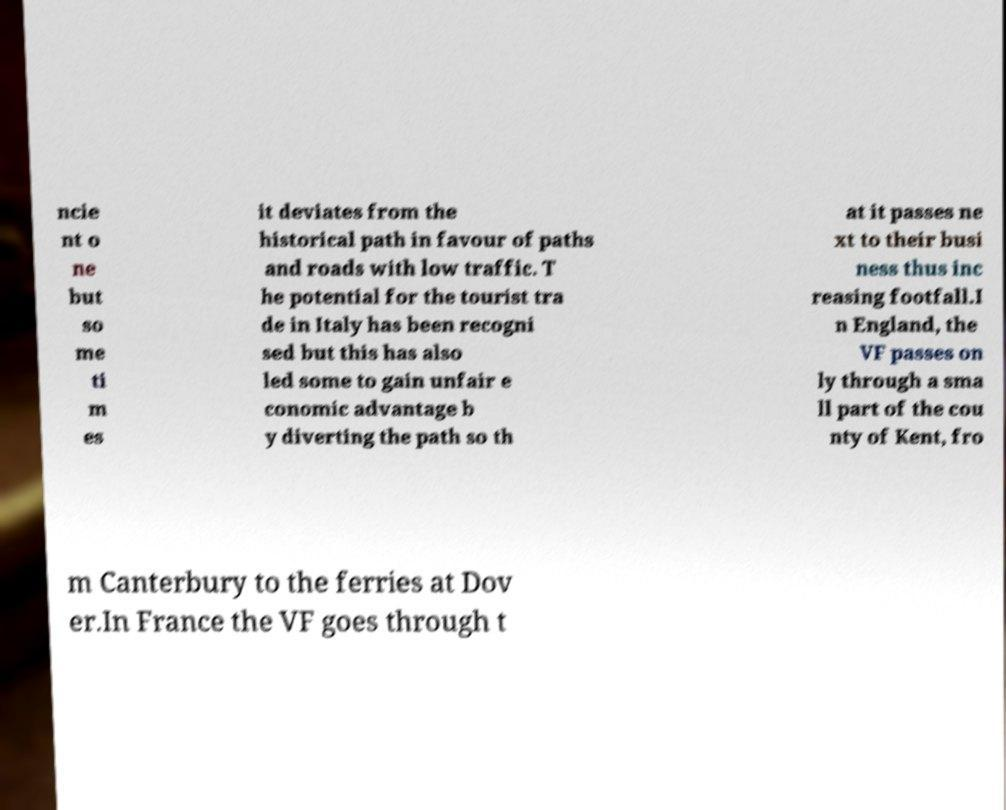For documentation purposes, I need the text within this image transcribed. Could you provide that? ncie nt o ne but so me ti m es it deviates from the historical path in favour of paths and roads with low traffic. T he potential for the tourist tra de in Italy has been recogni sed but this has also led some to gain unfair e conomic advantage b y diverting the path so th at it passes ne xt to their busi ness thus inc reasing footfall.I n England, the VF passes on ly through a sma ll part of the cou nty of Kent, fro m Canterbury to the ferries at Dov er.In France the VF goes through t 